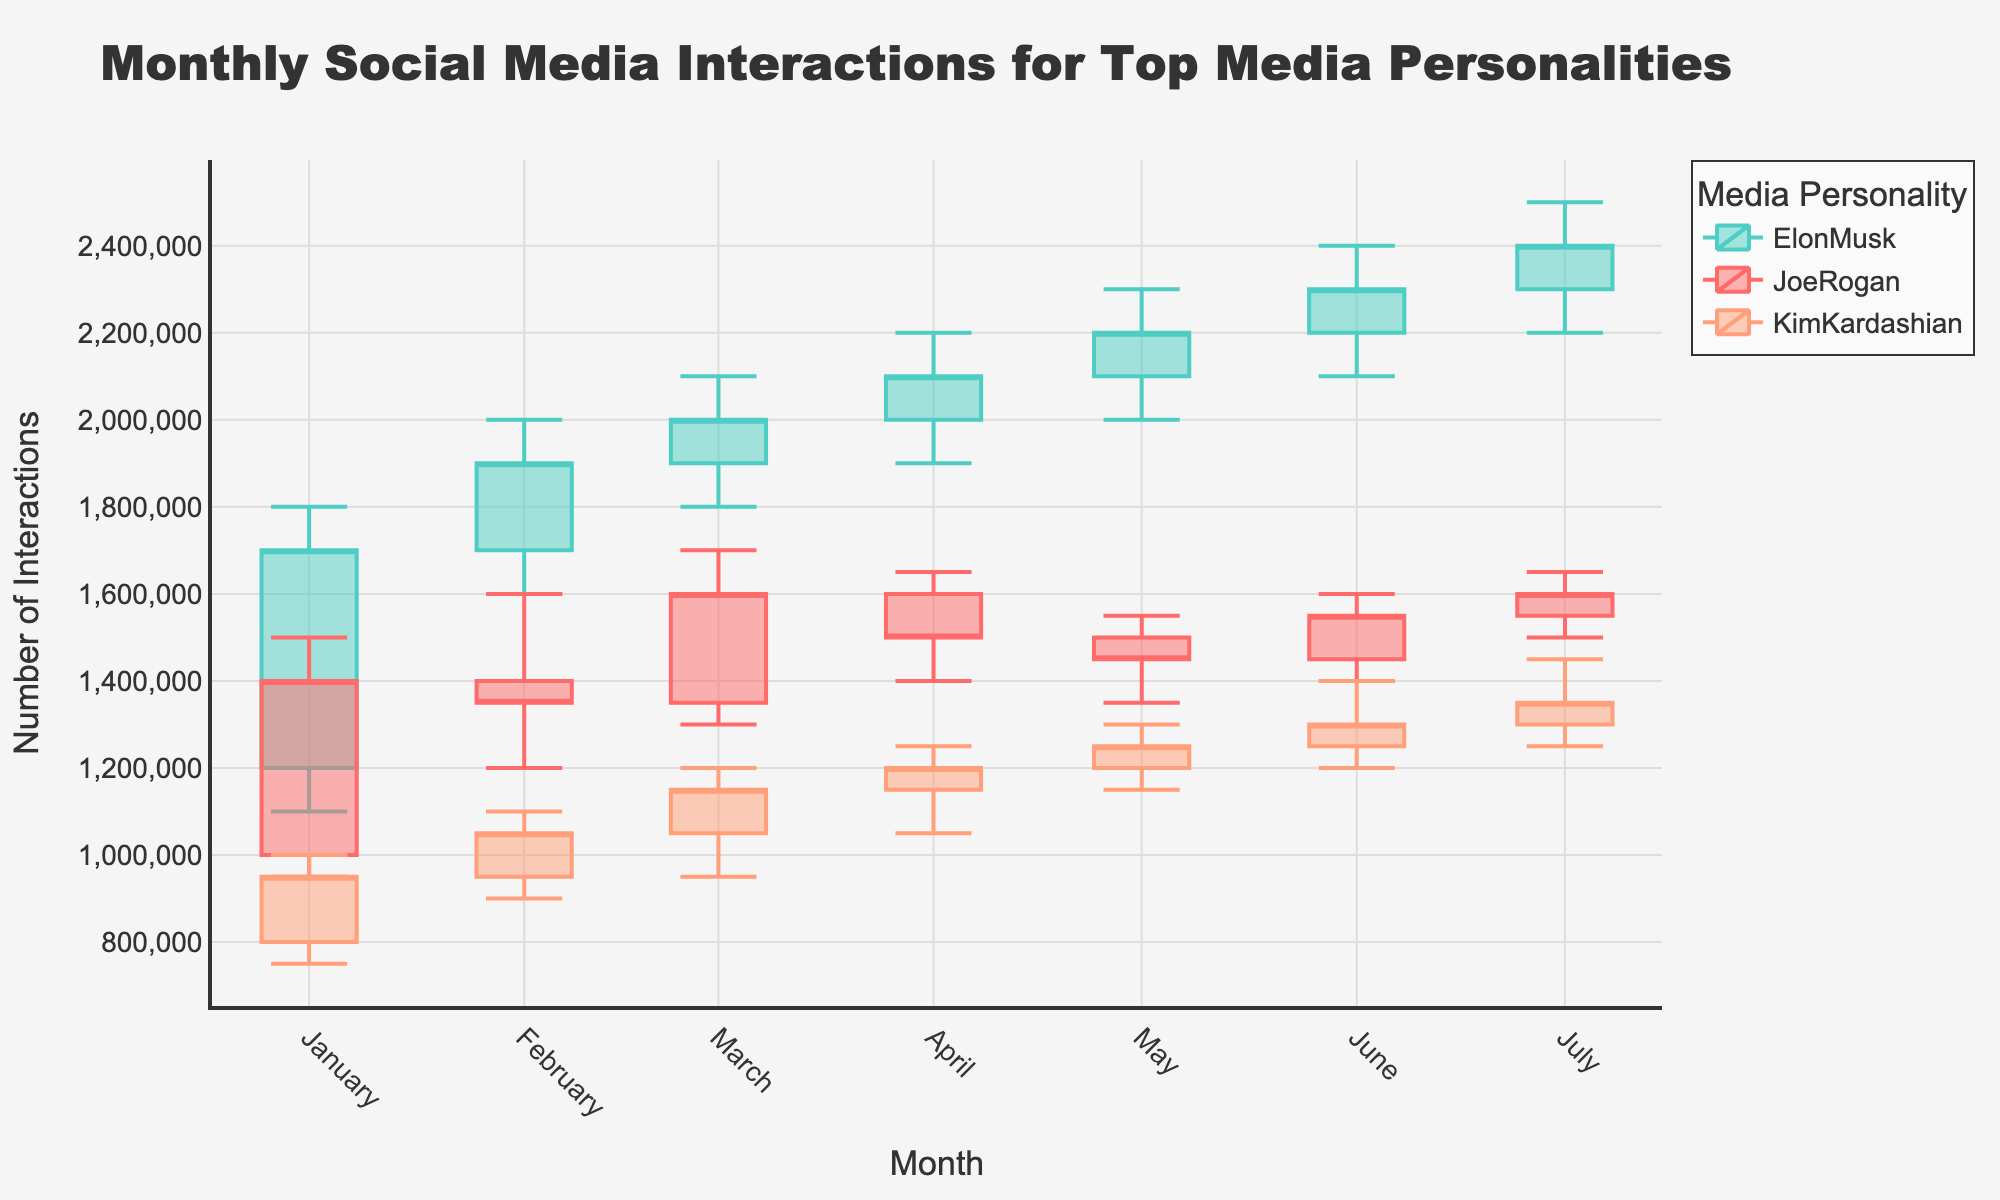Which media personality has the highest interactions in March? By looking at the candlestick for March, we need to identify the media personality whose "High" value is the greatest. Elon Musk has a "High" interaction of 2,100,000 in March, which is higher than Joe Rogan's 1,700,000 and Kim Kardashian's 1,200,000.
Answer: Elon Musk What's the difference between the highest and lowest interactions for Joe Rogan in April? In April, Joe Rogan's highest interaction is 1,650,000 (High) and the lowest is 1,400,000 (Low). Subtract the Low from the High: 1,650,000 - 1,400,000.
Answer: 250,000 Which media personality had an increasing trend in monthly interactions from February to March? We observe the "Close" values from February to March for all three media personalities. Joe Rogan's count increased from 1,350,000 to 1,600,000, indicating an increasing trend. Similarly, Elon Musk's interactions increased from 1,900,000 to 2,000,000. Kim Kardashian's interactions also increased from 1,050,000 to 1,150,000. Hence, all three personalities had an increasing trend.
Answer: Joe Rogan, Elon Musk, Kim Kardashian How many data points are shown for each media personality? The figure contains data points for 7 months (from January to July) for each of the three media personalities.
Answer: 7 Compare the average "Close" interactions in July for Joe Rogan, Elon Musk, and Kim Kardashian. Who has the highest average? The "Close" values for July are Joe Rogan (1,600,000), Elon Musk (2,400,000), and Kim Kardashian (1,350,000). Elon Musk has the highest average "Close" interaction among the three.
Answer: Elon Musk What is the median "Close" value for Kim Kardashian across the shown months? The "Close" values for Kim Kardashian across the months (January to July) are: 950,000, 1,050,000, 1,150,000, 1,200,000, 1,250,000, 1,300,000, 1,350,000. The median is the middle value when these numbers are ordered: 1,200,000.
Answer: 1,200,000 For which month did Elon Musk have the biggest increase in interactions? By comparing the "Open" and "Close" values each month for Elon Musk, we look for the largest difference (Increase = Close - Open). The biggest increase is in February where the difference is 1,900,000 - 1,700,000 = 200,000.
Answer: February 